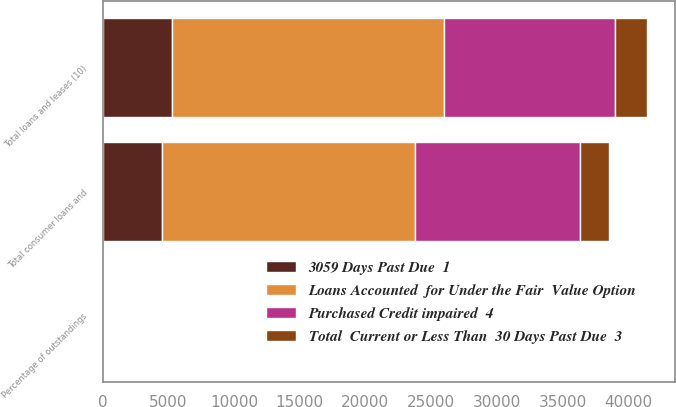Convert chart. <chart><loc_0><loc_0><loc_500><loc_500><stacked_bar_chart><ecel><fcel>Total consumer loans and<fcel>Total loans and leases (10)<fcel>Percentage of outstandings<nl><fcel>3059 Days Past Due  1<fcel>4532<fcel>5251<fcel>0.59<nl><fcel>Total  Current or Less Than  30 Days Past Due  3<fcel>2230<fcel>2460<fcel>0.27<nl><fcel>Purchased Credit impaired  4<fcel>12513<fcel>13020<fcel>1.45<nl><fcel>Loans Accounted  for Under the Fair  Value Option<fcel>19275<fcel>20731<fcel>2.31<nl></chart> 